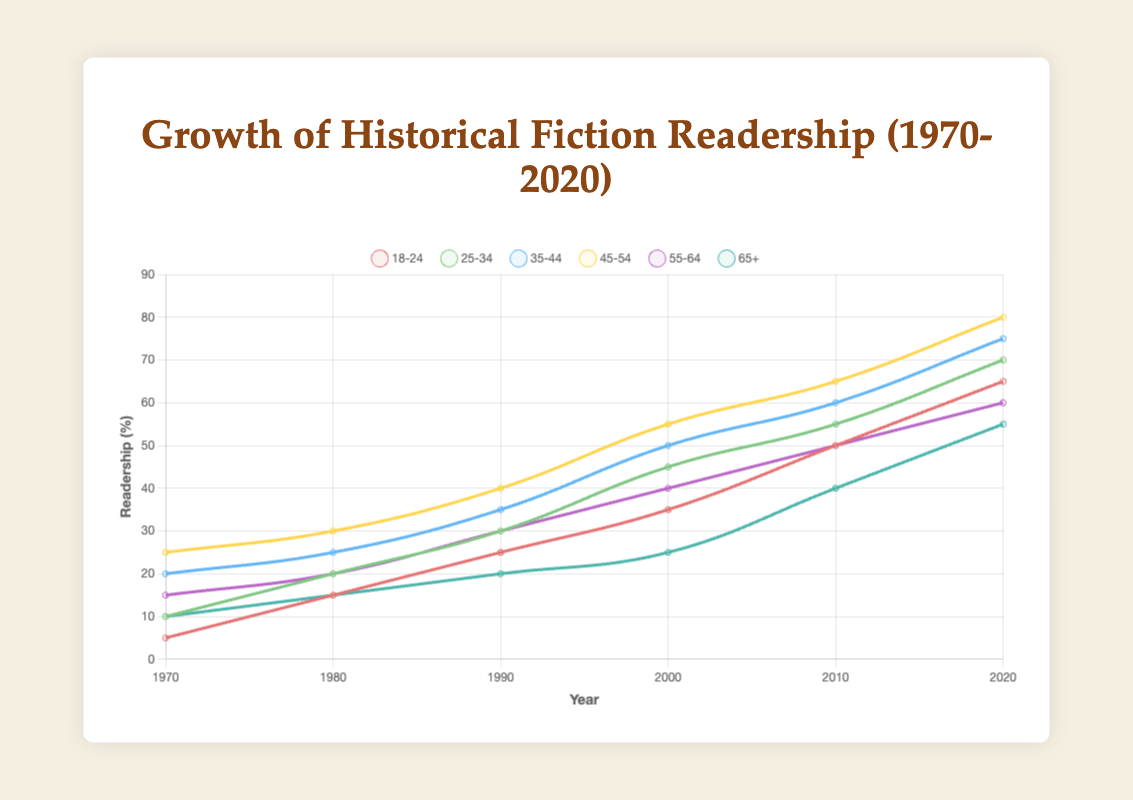What trend do we see among the 18-24 age group from 1970 to 2020? The 18-24 age group shows a consistent increase in readership percentages over the years from 1970 (5%) to 2020 (65%).
Answer: An increase Which age group had the highest readership in 2020? In 2020, the 45-54 age group had the highest readership percentage at 80%.
Answer: 45-54 age group By how much did the readership percentage for the 25-34 age group increase between 1980 and 2020? The readership percentage for the 25-34 age group was 20% in 1980 and 70% in 2020. The increase is 70% - 20% = 50%.
Answer: 50% Which age group saw the smallest change in readership from 1970 to 1990? The smallest change in readership from 1970 to 1990 is for the 65+ age group, which increased only by 10% (from 10% to 20%).
Answer: 65+ age group Based on the visual attributes, which age group's line is represented in blue? The age 35-44 group's line is represented in blue.
Answer: 35-44 age group What is the difference in readership between the 55-64 age group and the 65+ age group in 2020? In 2020, the readership for the 55-64 age group is 60%, and for the 65+ age group, it is 55%. The difference is 60% - 55% = 5%.
Answer: 5% Which two age groups had an equal readership percentage in 1980? In 1980, both the 18-24 and 65+ age groups had a readership percentage of 15%.
Answer: 18-24 and 65+ age groups What is the average readership percentage for the 45-54 age group across all six years? Summing up the percentages for the 45-54 age group: 25 + 30 + 40 + 55 + 65 + 80 = 295. The average is 295 / 6 ≈ 49.17%.
Answer: 49.17% Which age group had the highest increase in readership from 2000 to 2020? The 18-24 age group increased from 35% in 2000 to 65% in 2020, an increase of 30%. This is the highest increase.
Answer: 18-24 age group In which decade did the 35-44 age group see the largest increase in readership percentage? The largest increase for the 35-44 age group was from 1990 (35%) to 2000 (50%), an increase of 15%.
Answer: 1990-2000 